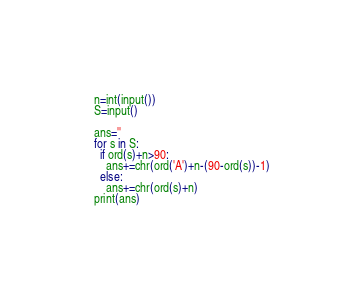<code> <loc_0><loc_0><loc_500><loc_500><_Python_>n=int(input())
S=input()

ans=''
for s in S:
  if ord(s)+n>90:
    ans+=chr(ord('A')+n-(90-ord(s))-1)
  else:
    ans+=chr(ord(s)+n)
print(ans)</code> 